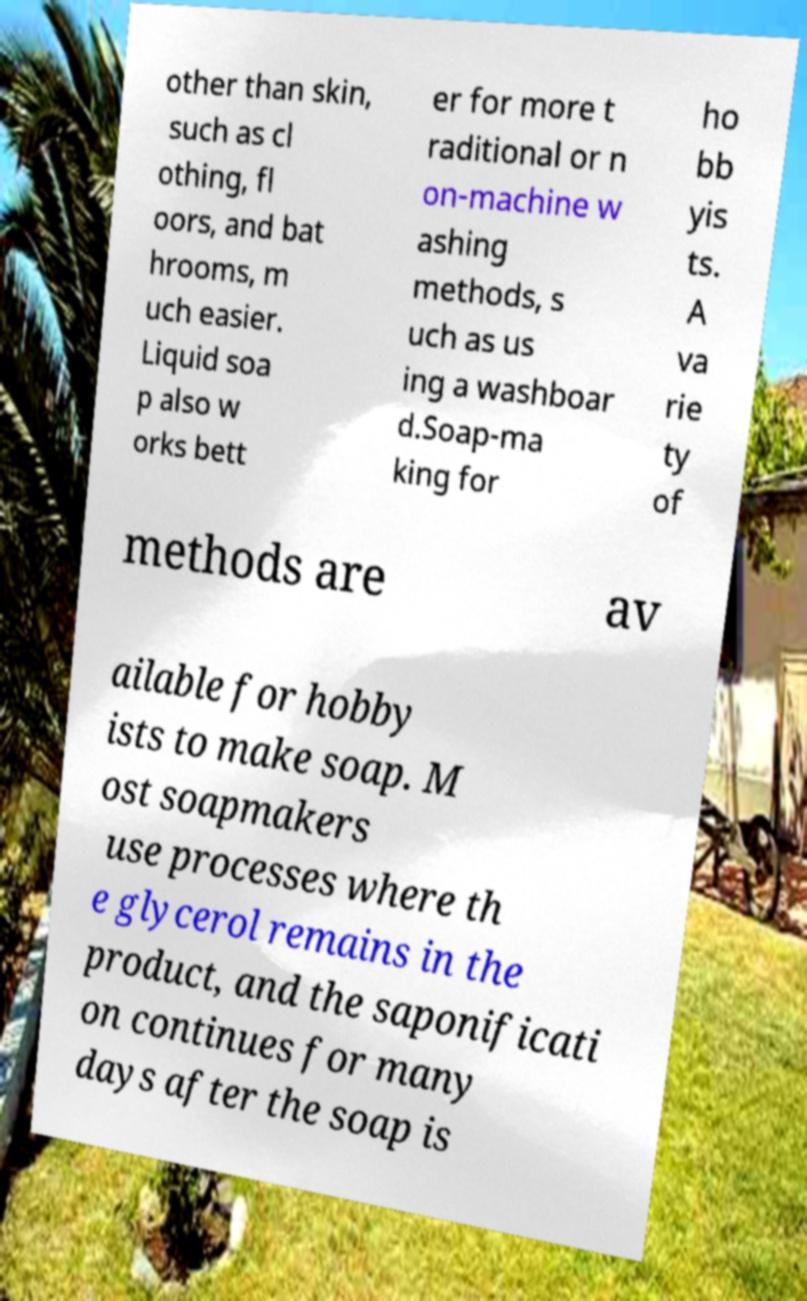For documentation purposes, I need the text within this image transcribed. Could you provide that? other than skin, such as cl othing, fl oors, and bat hrooms, m uch easier. Liquid soa p also w orks bett er for more t raditional or n on-machine w ashing methods, s uch as us ing a washboar d.Soap-ma king for ho bb yis ts. A va rie ty of methods are av ailable for hobby ists to make soap. M ost soapmakers use processes where th e glycerol remains in the product, and the saponificati on continues for many days after the soap is 